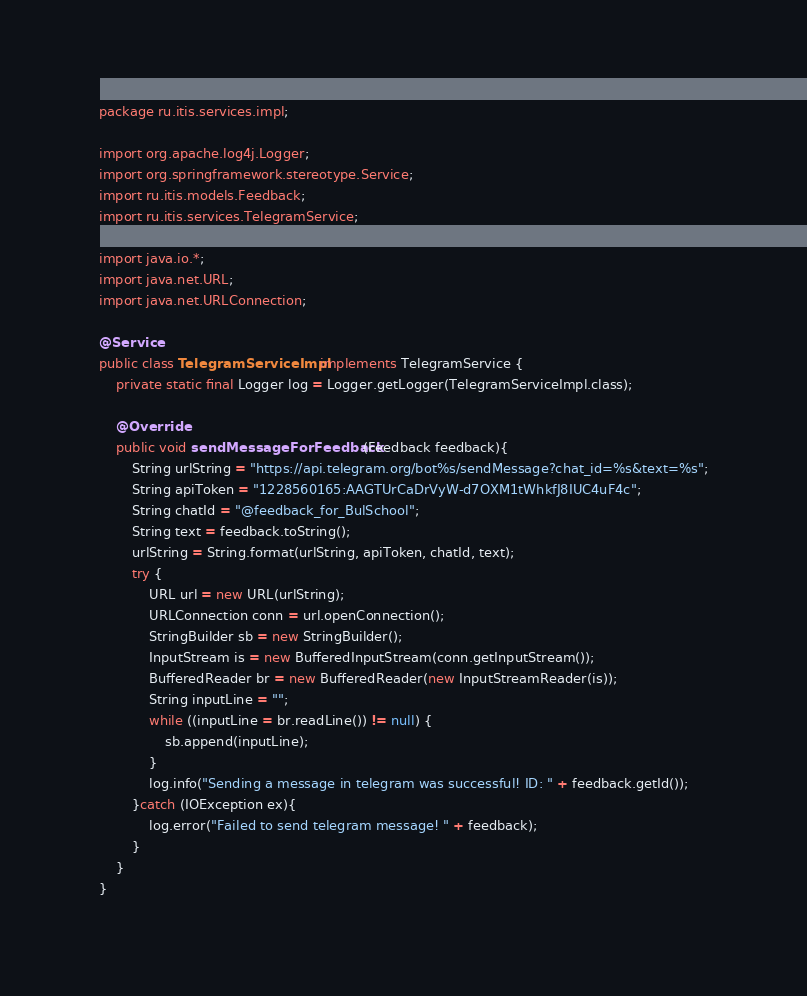Convert code to text. <code><loc_0><loc_0><loc_500><loc_500><_Java_>package ru.itis.services.impl;

import org.apache.log4j.Logger;
import org.springframework.stereotype.Service;
import ru.itis.models.Feedback;
import ru.itis.services.TelegramService;

import java.io.*;
import java.net.URL;
import java.net.URLConnection;

@Service
public class TelegramServiceImpl implements TelegramService {
    private static final Logger log = Logger.getLogger(TelegramServiceImpl.class);

    @Override
    public void sendMessageForFeedback(Feedback feedback){
        String urlString = "https://api.telegram.org/bot%s/sendMessage?chat_id=%s&text=%s";
        String apiToken = "1228560165:AAGTUrCaDrVyW-d7OXM1tWhkfJ8IUC4uF4c";
        String chatId = "@feedback_for_BulSchool";
        String text = feedback.toString();
        urlString = String.format(urlString, apiToken, chatId, text);
        try {
            URL url = new URL(urlString);
            URLConnection conn = url.openConnection();
            StringBuilder sb = new StringBuilder();
            InputStream is = new BufferedInputStream(conn.getInputStream());
            BufferedReader br = new BufferedReader(new InputStreamReader(is));
            String inputLine = "";
            while ((inputLine = br.readLine()) != null) {
                sb.append(inputLine);
            }
            log.info("Sending a message in telegram was successful! ID: " + feedback.getId());
        }catch (IOException ex){
            log.error("Failed to send telegram message! " + feedback);
        }
    }
}
</code> 